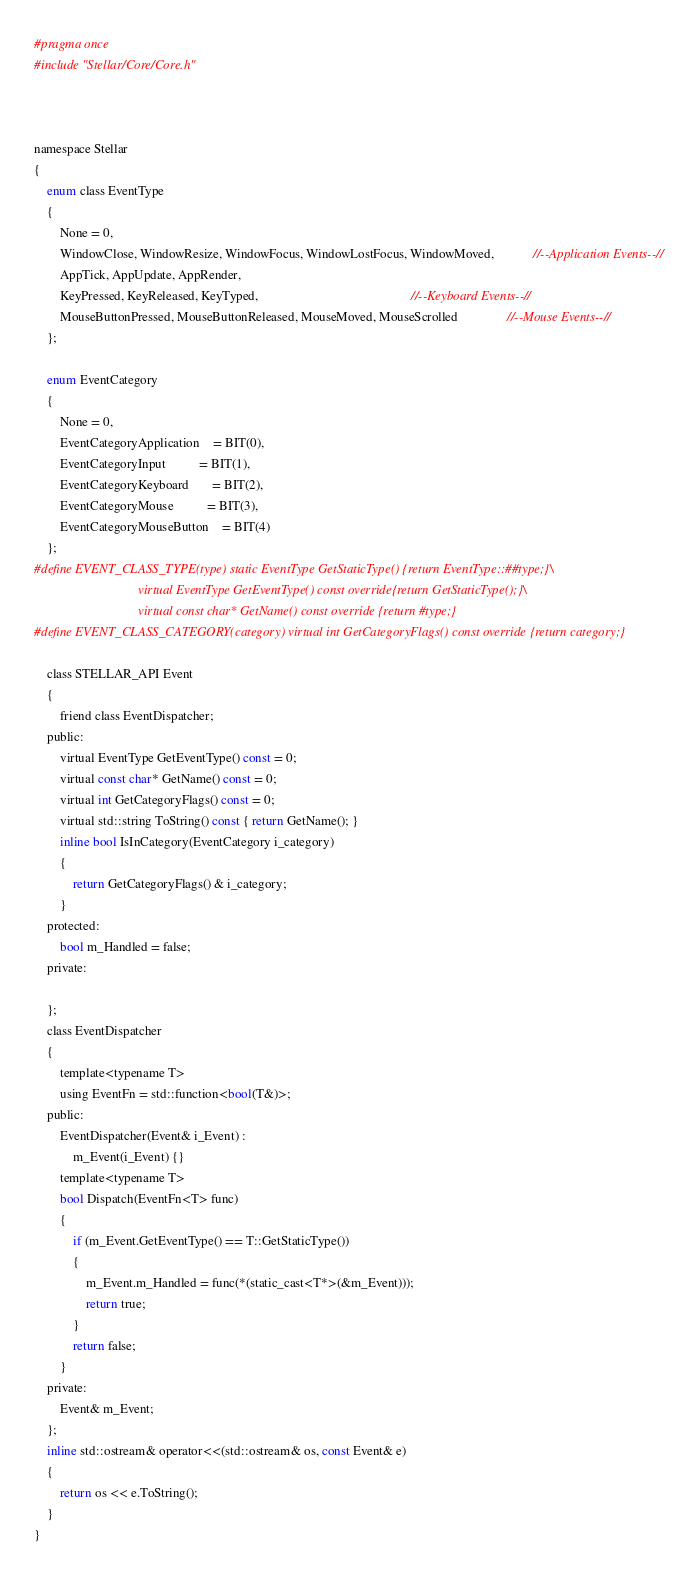<code> <loc_0><loc_0><loc_500><loc_500><_C_>#pragma once
#include "Stellar/Core/Core.h"



namespace Stellar
{
	enum class EventType
	{
		None = 0,
		WindowClose, WindowResize, WindowFocus, WindowLostFocus, WindowMoved,            //--Application Events--//
		AppTick, AppUpdate, AppRender,
		KeyPressed, KeyReleased, KeyTyped,                                               //--Keyboard Events--//
		MouseButtonPressed, MouseButtonReleased, MouseMoved, MouseScrolled               //--Mouse Events--//
	};

	enum EventCategory
	{
		None = 0,
		EventCategoryApplication    = BIT(0),
		EventCategoryInput          = BIT(1),
		EventCategoryKeyboard       = BIT(2),
		EventCategoryMouse          = BIT(3),
		EventCategoryMouseButton    = BIT(4)
	};
#define EVENT_CLASS_TYPE(type) static EventType GetStaticType() {return EventType::##type;}\
								virtual EventType GetEventType() const override{return GetStaticType();}\
								virtual const char* GetName() const override {return #type;} 
#define EVENT_CLASS_CATEGORY(category) virtual int GetCategoryFlags() const override {return category;}

	class STELLAR_API Event
	{
		friend class EventDispatcher;
	public:
		virtual EventType GetEventType() const = 0;
		virtual const char* GetName() const = 0;
		virtual int GetCategoryFlags() const = 0;
		virtual std::string ToString() const { return GetName(); }
		inline bool IsInCategory(EventCategory i_category)
		{
			return GetCategoryFlags() & i_category;
		}
	protected:
		bool m_Handled = false;
	private:

	};
	class EventDispatcher
	{
		template<typename T>
		using EventFn = std::function<bool(T&)>;
	public:
		EventDispatcher(Event& i_Event) :
			m_Event(i_Event) {}
		template<typename T>
		bool Dispatch(EventFn<T> func)
		{
			if (m_Event.GetEventType() == T::GetStaticType())
			{
				m_Event.m_Handled = func(*(static_cast<T*>(&m_Event)));
				return true;
			}
			return false;
		}
	private:
		Event& m_Event;
	};
	inline std::ostream& operator<<(std::ostream& os, const Event& e)
	{
		return os << e.ToString();
	}
}</code> 